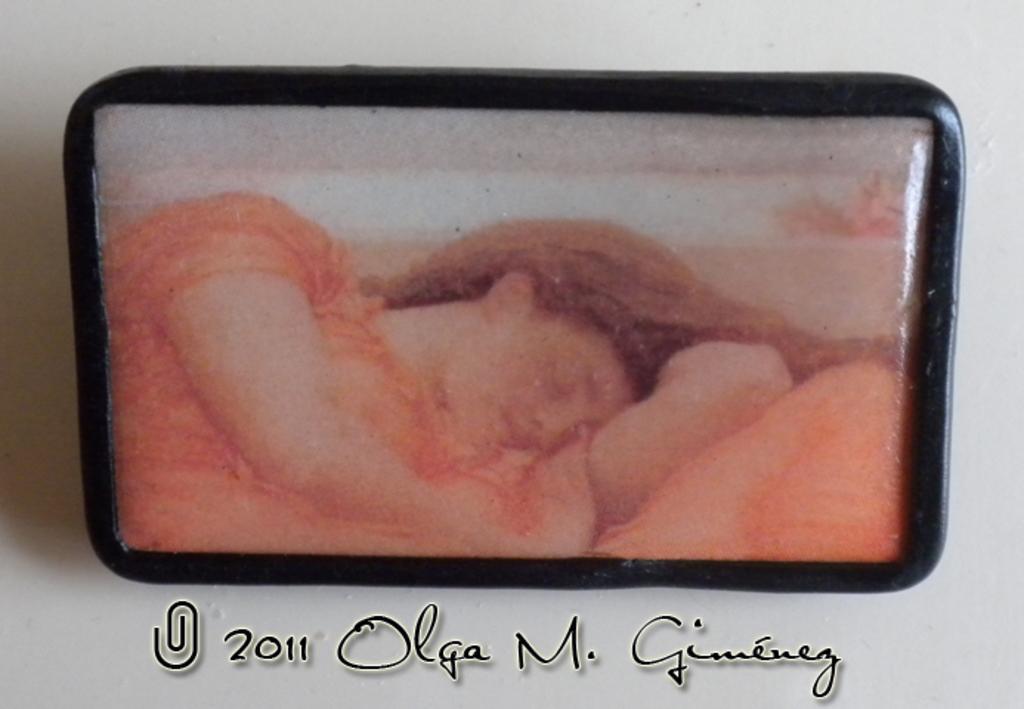Describe this image in one or two sentences. In this image there is a photo frame on the wall and text at the bottom. 